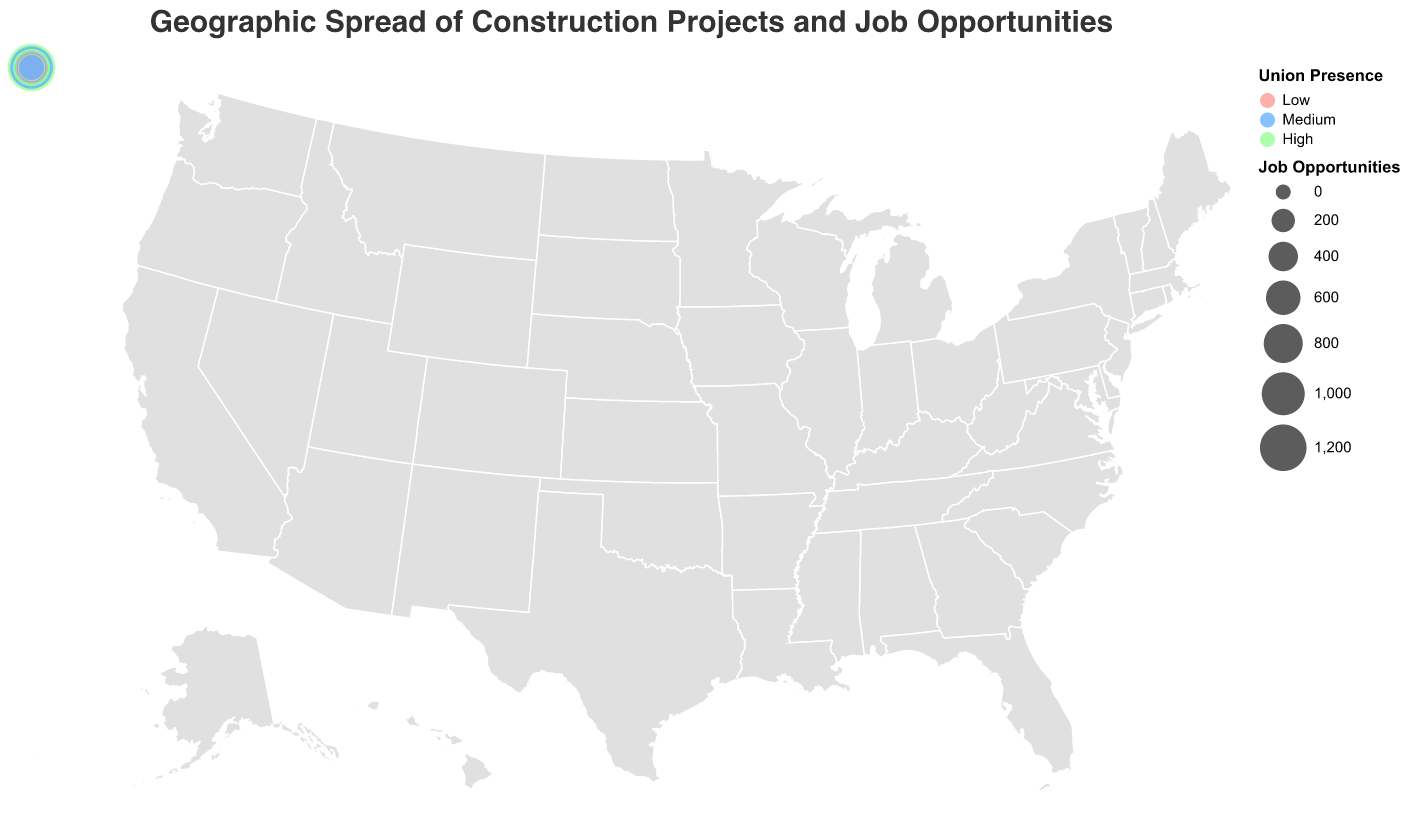What is the title of the figure? The title is found at the top of the plot and usually summarizes the main information displayed.
Answer: Geographic Spread of Construction Projects and Job Opportunities Which state has the highest number of construction projects? By looking at the size of the circles and comparing them, the largest circle corresponds to the state with the highest number of projects.
Answer: California Which states have a High union presence? Union presence is indicated by colors. The states with circles colored in green represent a high union presence.
Answer: California, New York, Illinois, Pennsylvania, Michigan, Massachusetts, Wisconsin How many job opportunities are there in Texas? Texas can be identified on the map, and by hovering over or looking at the tooltip information, you can get the number of job opportunities.
Answer: 980 Compare the number of job opportunities between New York and Illinois. From the tooltip information or by comparing the size of the circles for New York and Illinois, you can determine their job opportunities. New York has 750, and Illinois has 620.
Answer: New York has 130 more job opportunities than Illinois Which state has the lowest number of job opportunities and what is the union presence there? By identifying the smallest circle and checking its tooltip information, the state with the lowest job opportunities can be found along with the union presence indicated by color.
Answer: Oregon, Medium What is the average number of construction projects in the states with Medium and Low union presence? First, identify the states with Medium and Low union presence, sum their number of projects, and divide by the number of such states.
Medium (Texas, Florida, Ohio, Washington, Colorado, Minnesota, Missouri, Indiana, Oregon): (65+52+33+24+22+16+15+14+12)/9 = 28
Low (Georgia, North Carolina, Arizona, Tennessee): (28+26+21+13)/4 = 22
Answer: For Medium union presence, the average is 28 projects, and for Low union presence, it's 22 projects 